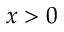<formula> <loc_0><loc_0><loc_500><loc_500>x > 0</formula> 